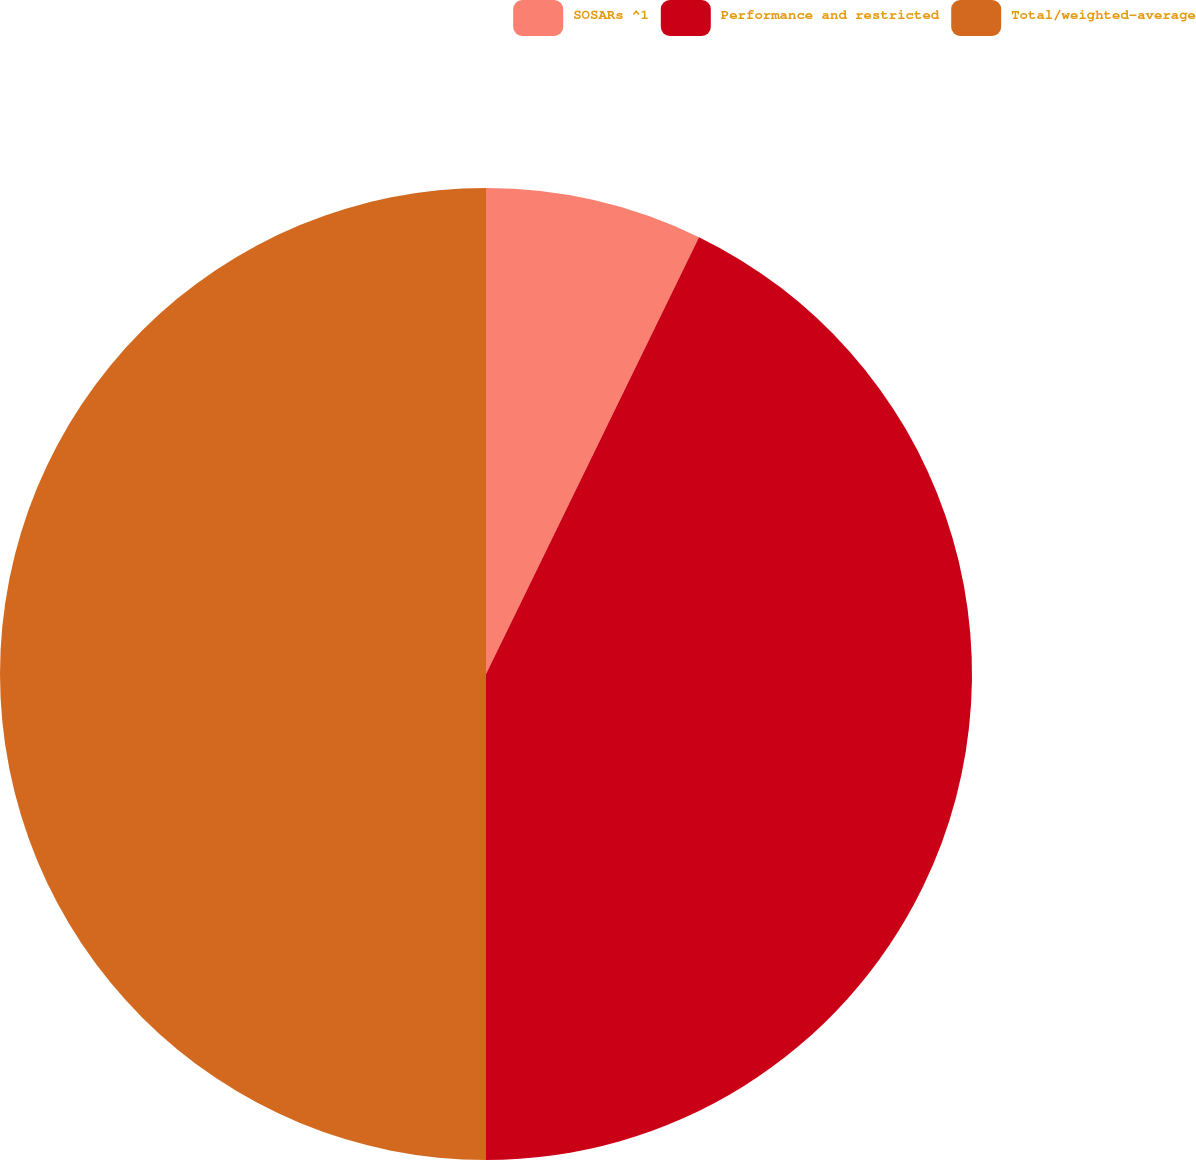<chart> <loc_0><loc_0><loc_500><loc_500><pie_chart><fcel>SOSARs ^1<fcel>Performance and restricted<fcel>Total/weighted-average<nl><fcel>7.22%<fcel>42.78%<fcel>50.0%<nl></chart> 